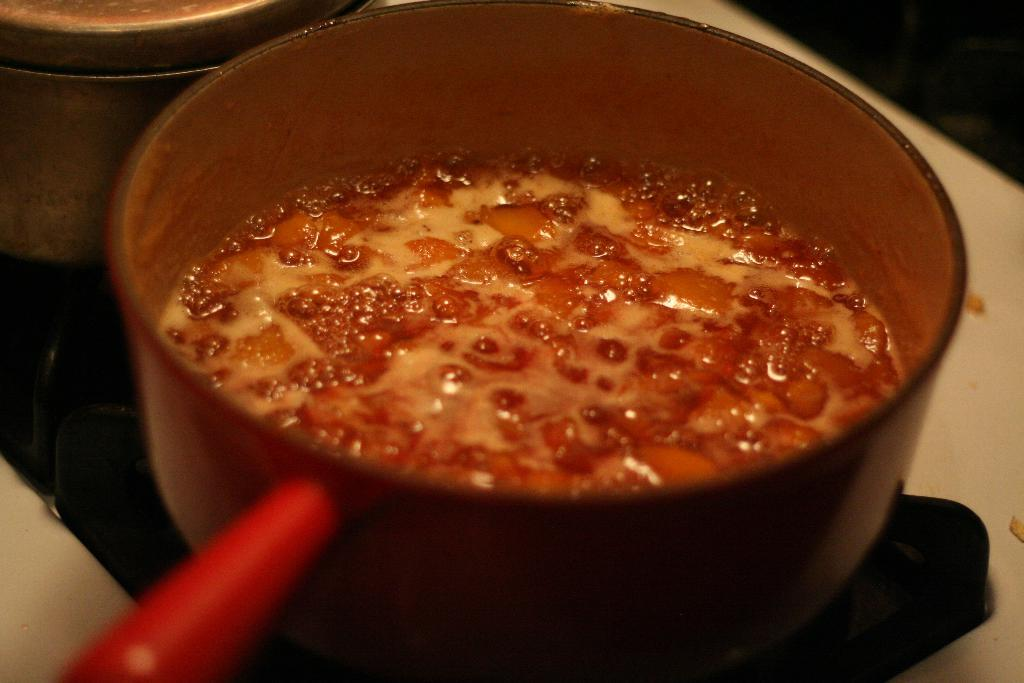What type of cooking appliance is present in the image? There is a stove in the image. What is being cooked on the stove? There is a pan with a food item on the stove, and there is another vessel on the stove as well. What type of juice can be seen being poured from the stove in the image? There is no juice present in the image; it features a stove with a pan and another vessel containing food items. 